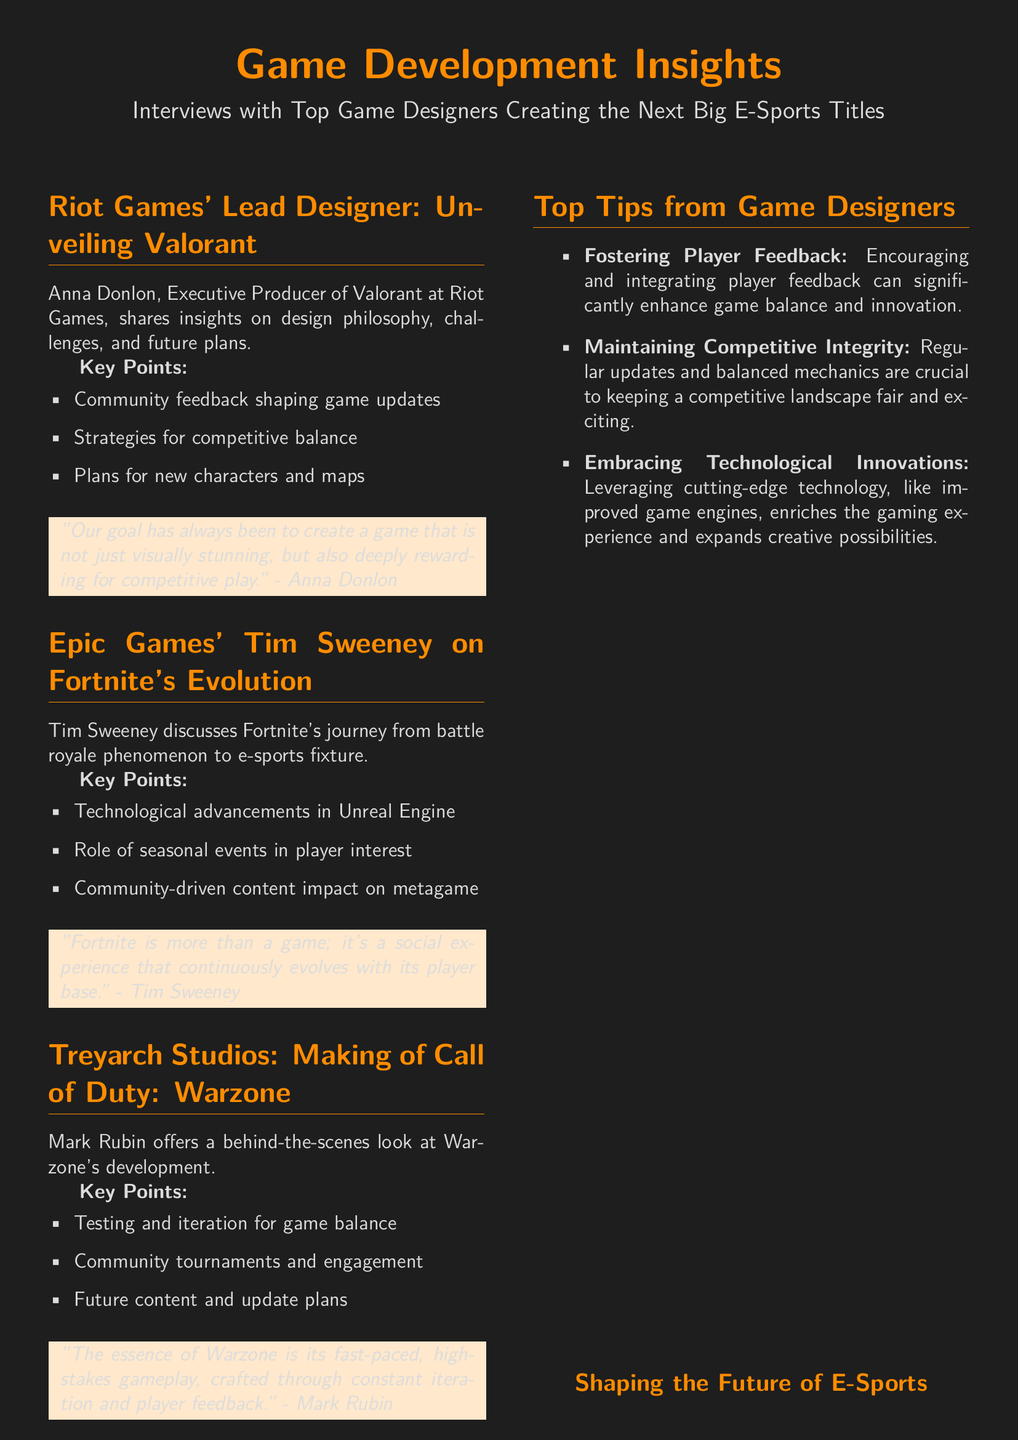What is the title of the document? The document title is presented at the center of the first page, highlighting the main focus of the content.
Answer: Game Development Insights Who is the Executive Producer of Valorant? The document specifies Anna Donlon as the Executive Producer of Valorant in the section dedicated to Riot Games.
Answer: Anna Donlon What studio is Tim Sweeney affiliated with? In the segment about Fortnite, the document clearly states Tim Sweeney's association with a specific game studio.
Answer: Epic Games What are the key points discussed by Mark Rubin? Mark Rubin's section encompasses specific key points related to Warzone, offering insights into its development process.
Answer: Testing and iteration for game balance, Community tournaments and engagement, Future content and update plans How does Anna Donlon describe the goal of the game? A quote from Anna Donlon is included, summarizing the core aspiration behind game design for Valorant.
Answer: "Our goal has always been to create a game that is not just visually stunning, but also deeply rewarding for competitive play." What is emphasized as crucial for maintaining competitive integrity? The document outlines essential strategies for keeping the game's competitive environment well-structured and engaging.
Answer: Regular updates and balanced mechanics What is noted as the essence of Warzone? Mark Rubin articulates what defines the gameplay experience in Warzone, shedding light on its unique traits.
Answer: Fast-paced, high-stakes gameplay What is the main theme of the tips offered by game designers? The tips section encapsulates a focus on several actionable strategies that developers can utilize to enhance their games.
Answer: Fostering Player Feedback, Maintaining Competitive Integrity, Embracing Technological Innovations 